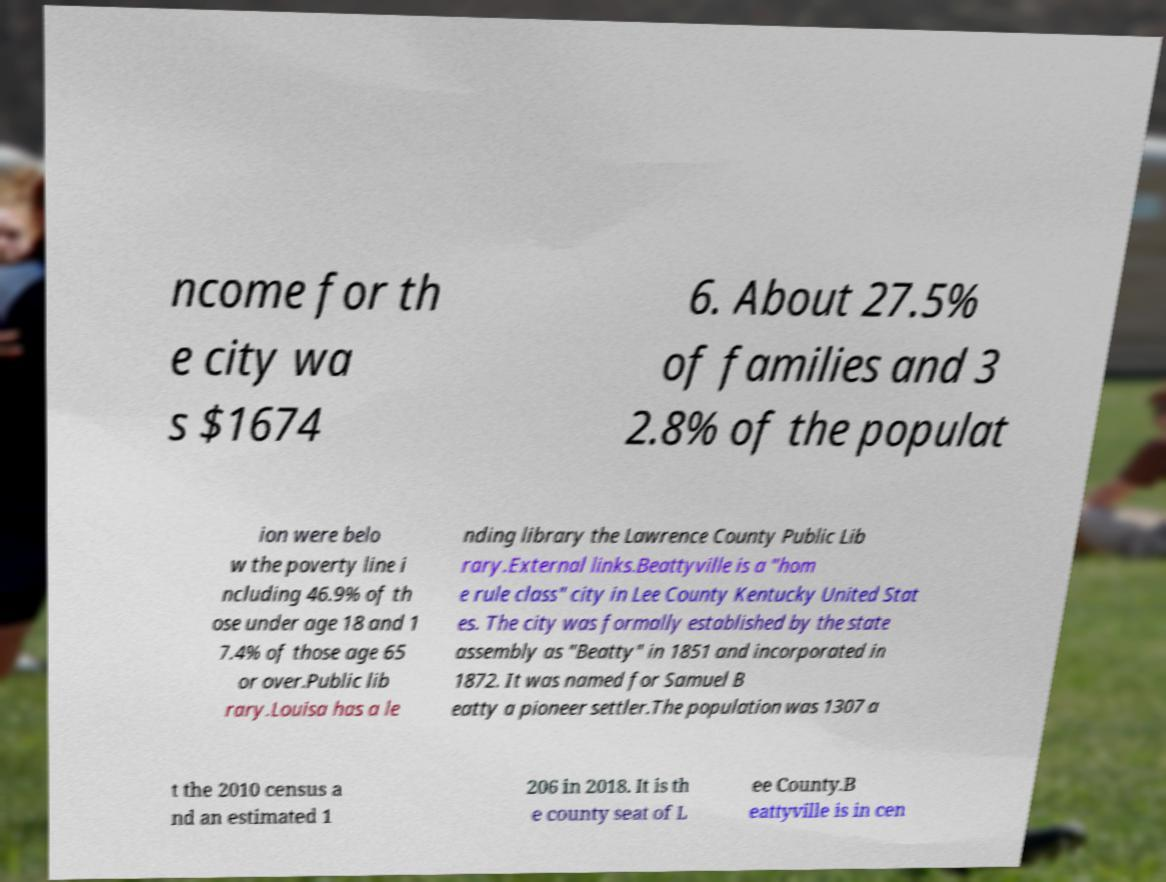For documentation purposes, I need the text within this image transcribed. Could you provide that? ncome for th e city wa s $1674 6. About 27.5% of families and 3 2.8% of the populat ion were belo w the poverty line i ncluding 46.9% of th ose under age 18 and 1 7.4% of those age 65 or over.Public lib rary.Louisa has a le nding library the Lawrence County Public Lib rary.External links.Beattyville is a "hom e rule class" city in Lee County Kentucky United Stat es. The city was formally established by the state assembly as "Beatty" in 1851 and incorporated in 1872. It was named for Samuel B eatty a pioneer settler.The population was 1307 a t the 2010 census a nd an estimated 1 206 in 2018. It is th e county seat of L ee County.B eattyville is in cen 